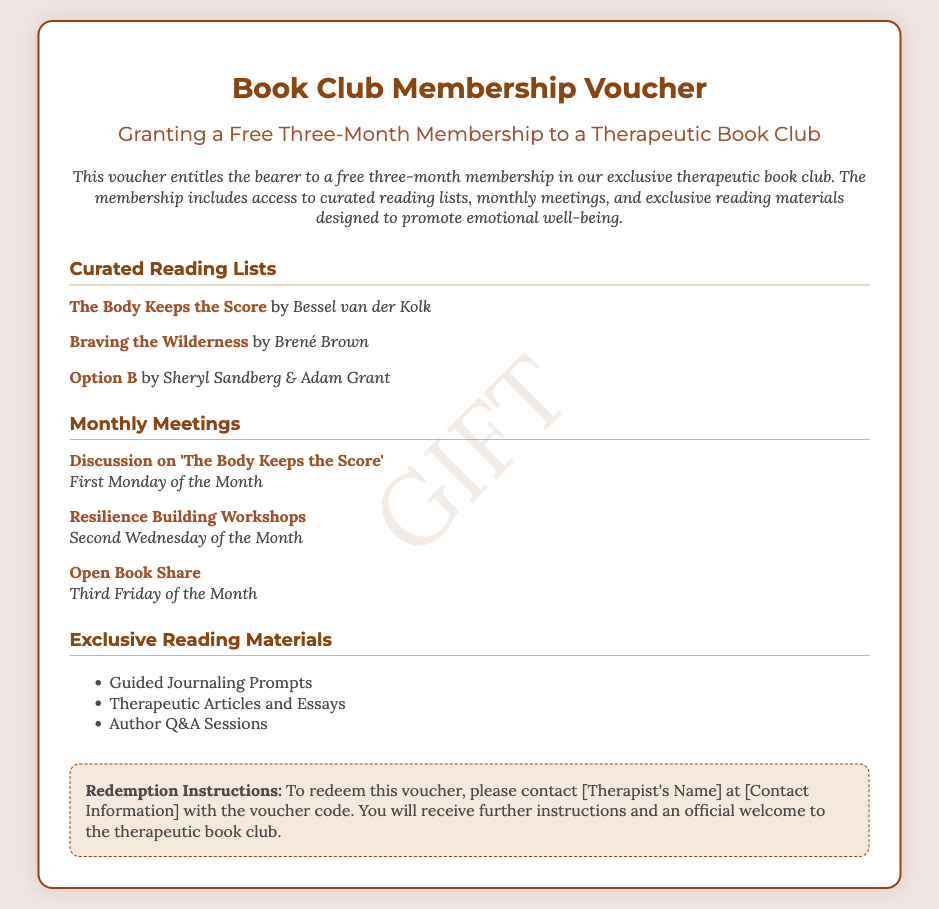what is the duration of the membership? The membership duration is explicitly stated as a "free three-month membership."
Answer: three-month who is the author of "Braving the Wilderness"? The document lists "Braving the Wilderness" with its author, Brené Brown.
Answer: Brené Brown when is the discussion on 'The Body Keeps the Score'? The document specifies that this discussion takes place on the "First Monday of the Month."
Answer: First Monday what type of prompts are included in the exclusive reading materials? The document mentions "Guided Journaling Prompts" as part of the exclusive reading materials.
Answer: Guided Journaling Prompts how many monthly meetings are listed in the document? The document lists three monthly meetings described in two sections.
Answer: three what is required to redeem the voucher? The redemption instructions state that you need to contact [Therapist's Name] at [Contact Information].
Answer: contact [Therapist's Name] what is the title of the first book in the curated reading list? The first book listed in the curated reading lists is "The Body Keeps the Score."
Answer: The Body Keeps the Score what is the color of the voucher's header text? The header text color in the voucher is specified as “#8b4513.”
Answer: #8b4513 what does the voucher grant access to apart from reading lists? It grants access to "monthly meetings" and "exclusive reading materials" in addition to reading lists.
Answer: monthly meetings and exclusive reading materials 